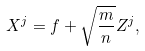<formula> <loc_0><loc_0><loc_500><loc_500>X ^ { j } = f + \sqrt { \frac { m } { n } } Z ^ { j } ,</formula> 